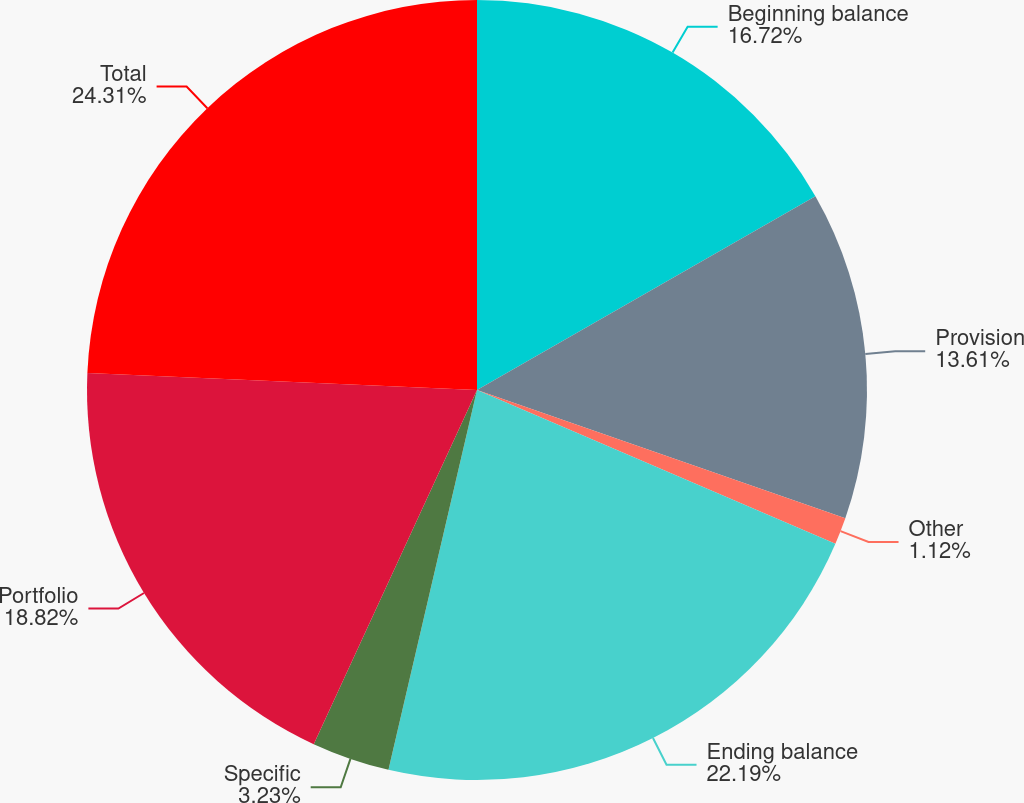<chart> <loc_0><loc_0><loc_500><loc_500><pie_chart><fcel>Beginning balance<fcel>Provision<fcel>Other<fcel>Ending balance<fcel>Specific<fcel>Portfolio<fcel>Total<nl><fcel>16.72%<fcel>13.61%<fcel>1.12%<fcel>22.19%<fcel>3.23%<fcel>18.82%<fcel>24.3%<nl></chart> 